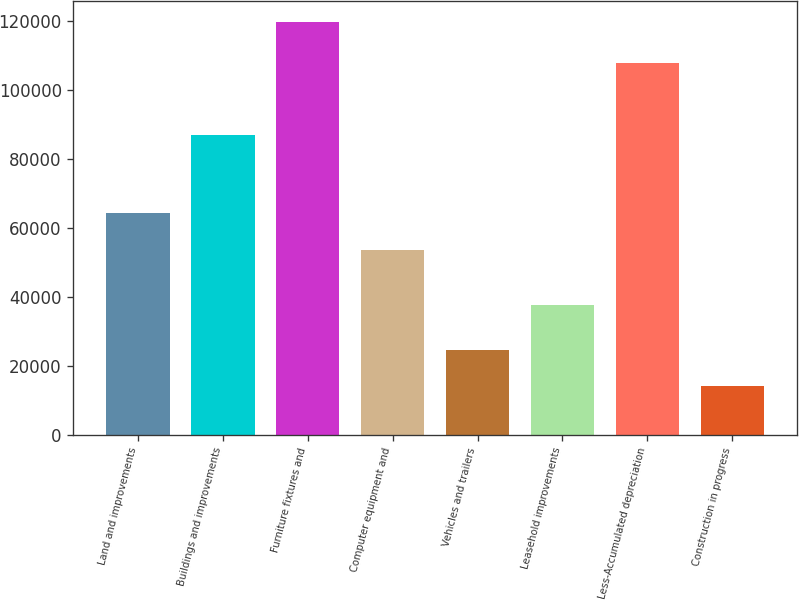Convert chart. <chart><loc_0><loc_0><loc_500><loc_500><bar_chart><fcel>Land and improvements<fcel>Buildings and improvements<fcel>Furniture fixtures and<fcel>Computer equipment and<fcel>Vehicles and trailers<fcel>Leasehold improvements<fcel>Less-Accumulated depreciation<fcel>Construction in progress<nl><fcel>64279.4<fcel>87083<fcel>119756<fcel>53710<fcel>24631.4<fcel>37608<fcel>107959<fcel>14062<nl></chart> 